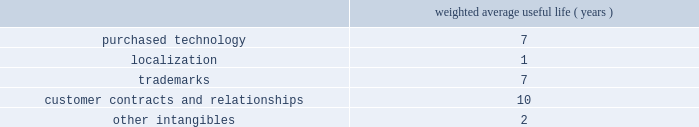Adobe systems incorporated notes to consolidated financial statements ( continued ) foreign currency translation we translate assets and liabilities of foreign subsidiaries , whose functional currency is their local currency , at exchange rates in effect at the balance sheet date .
We translate revenue and expenses at the monthly average exchange rates .
We include accumulated net translation adjustments in stockholders 2019 equity as a component of accumulated other comprehensive income .
Property and equipment we record property and equipment at cost less accumulated depreciation and amortization .
Property and equipment are depreciated using the straight-line method over their estimated useful lives ranging from 1 to 5 years for computers and equipment , 1 to 6 years for furniture and fixtures and up to 35 years for buildings .
Leasehold improvements are amortized using the straight-line method over the lesser of the remaining respective lease term or useful lives .
Goodwill , purchased intangibles and other long-lived assets we review our goodwill for impairment annually , or more frequently , if facts and circumstances warrant a review .
We completed our annual impairment test in the second quarter of fiscal 2009 and determined that there was no impairment .
Goodwill is assigned to one or more reporting segments on the date of acquisition .
We evaluate goodwill for impairment by comparing the fair value of each of our reporting segments to its carrying value , including the associated goodwill .
To determine the fair values , we use the market approach based on comparable publicly traded companies in similar lines of businesses and the income approach based on estimated discounted future cash flows .
Our cash flow assumptions consider historical and forecasted revenue , operating costs and other relevant factors .
We amortize intangible assets with finite lives over their estimated useful lives and review them for impairment whenever an impairment indicator exists .
We continually monitor events and changes in circumstances that could indicate carrying amounts of our long-lived assets , including our intangible assets may not be recoverable .
When such events or changes in circumstances occur , we assess recoverability by determining whether the carrying value of such assets will be recovered through the undiscounted expected future cash flows .
If the future undiscounted cash flows are less than the carrying amount of these assets , we recognize an impairment loss based on the excess of the carrying amount over the fair value of the assets .
We did not recognize any intangible asset impairment charges in fiscal 2009 , 2008 or 2007 .
Our intangible assets are amortized over their estimated useful lives of 1 to 13 years as shown in the table below .
Amortization is based on the pattern in which the economic benefits of the intangible asset will be consumed .
Weighted average useful life ( years ) .
Software development costs capitalization of software development costs for software to be sold , leased , or otherwise marketed begins upon the establishment of technological feasibility , which is generally the completion of a working prototype that has been certified as having no critical bugs and is a release candidate .
Amortization begins once the software is ready for its intended use , generally based on the pattern in which the economic benefits will be consumed .
To date , software development costs incurred between completion of a working prototype and general availability of the related product have not been material .
Revenue recognition our revenue is derived from the licensing of software products , consulting , hosting services and maintenance and support .
Primarily , we recognize revenue when persuasive evidence of an arrangement exists , we have delivered the product or performed the service , the fee is fixed or determinable and collection is probable. .
What is the average weighted average useful life ( years ) for trademarks and customer contracts and relationships? 
Computations: ((7 + 10) / 2)
Answer: 8.5. 